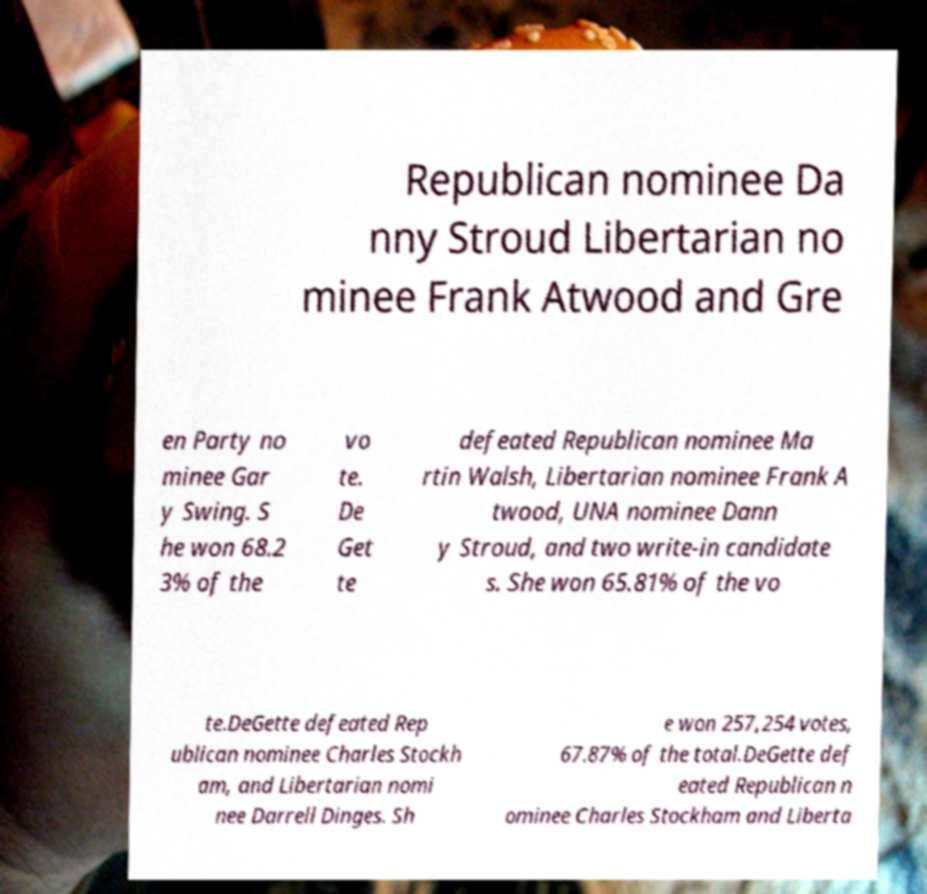For documentation purposes, I need the text within this image transcribed. Could you provide that? Republican nominee Da nny Stroud Libertarian no minee Frank Atwood and Gre en Party no minee Gar y Swing. S he won 68.2 3% of the vo te. De Get te defeated Republican nominee Ma rtin Walsh, Libertarian nominee Frank A twood, UNA nominee Dann y Stroud, and two write-in candidate s. She won 65.81% of the vo te.DeGette defeated Rep ublican nominee Charles Stockh am, and Libertarian nomi nee Darrell Dinges. Sh e won 257,254 votes, 67.87% of the total.DeGette def eated Republican n ominee Charles Stockham and Liberta 